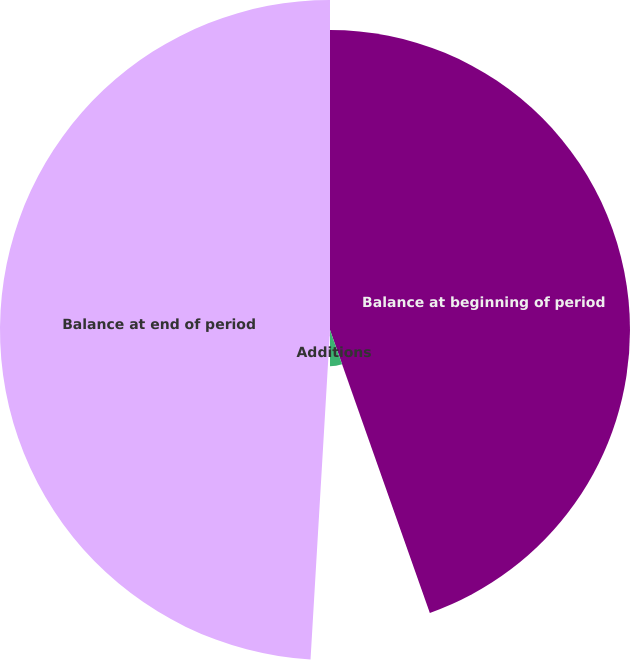Convert chart. <chart><loc_0><loc_0><loc_500><loc_500><pie_chart><fcel>Balance at beginning of period<fcel>Additions<fcel>Net retirements and other<fcel>Balance at end of period<nl><fcel>44.6%<fcel>5.4%<fcel>0.94%<fcel>49.06%<nl></chart> 